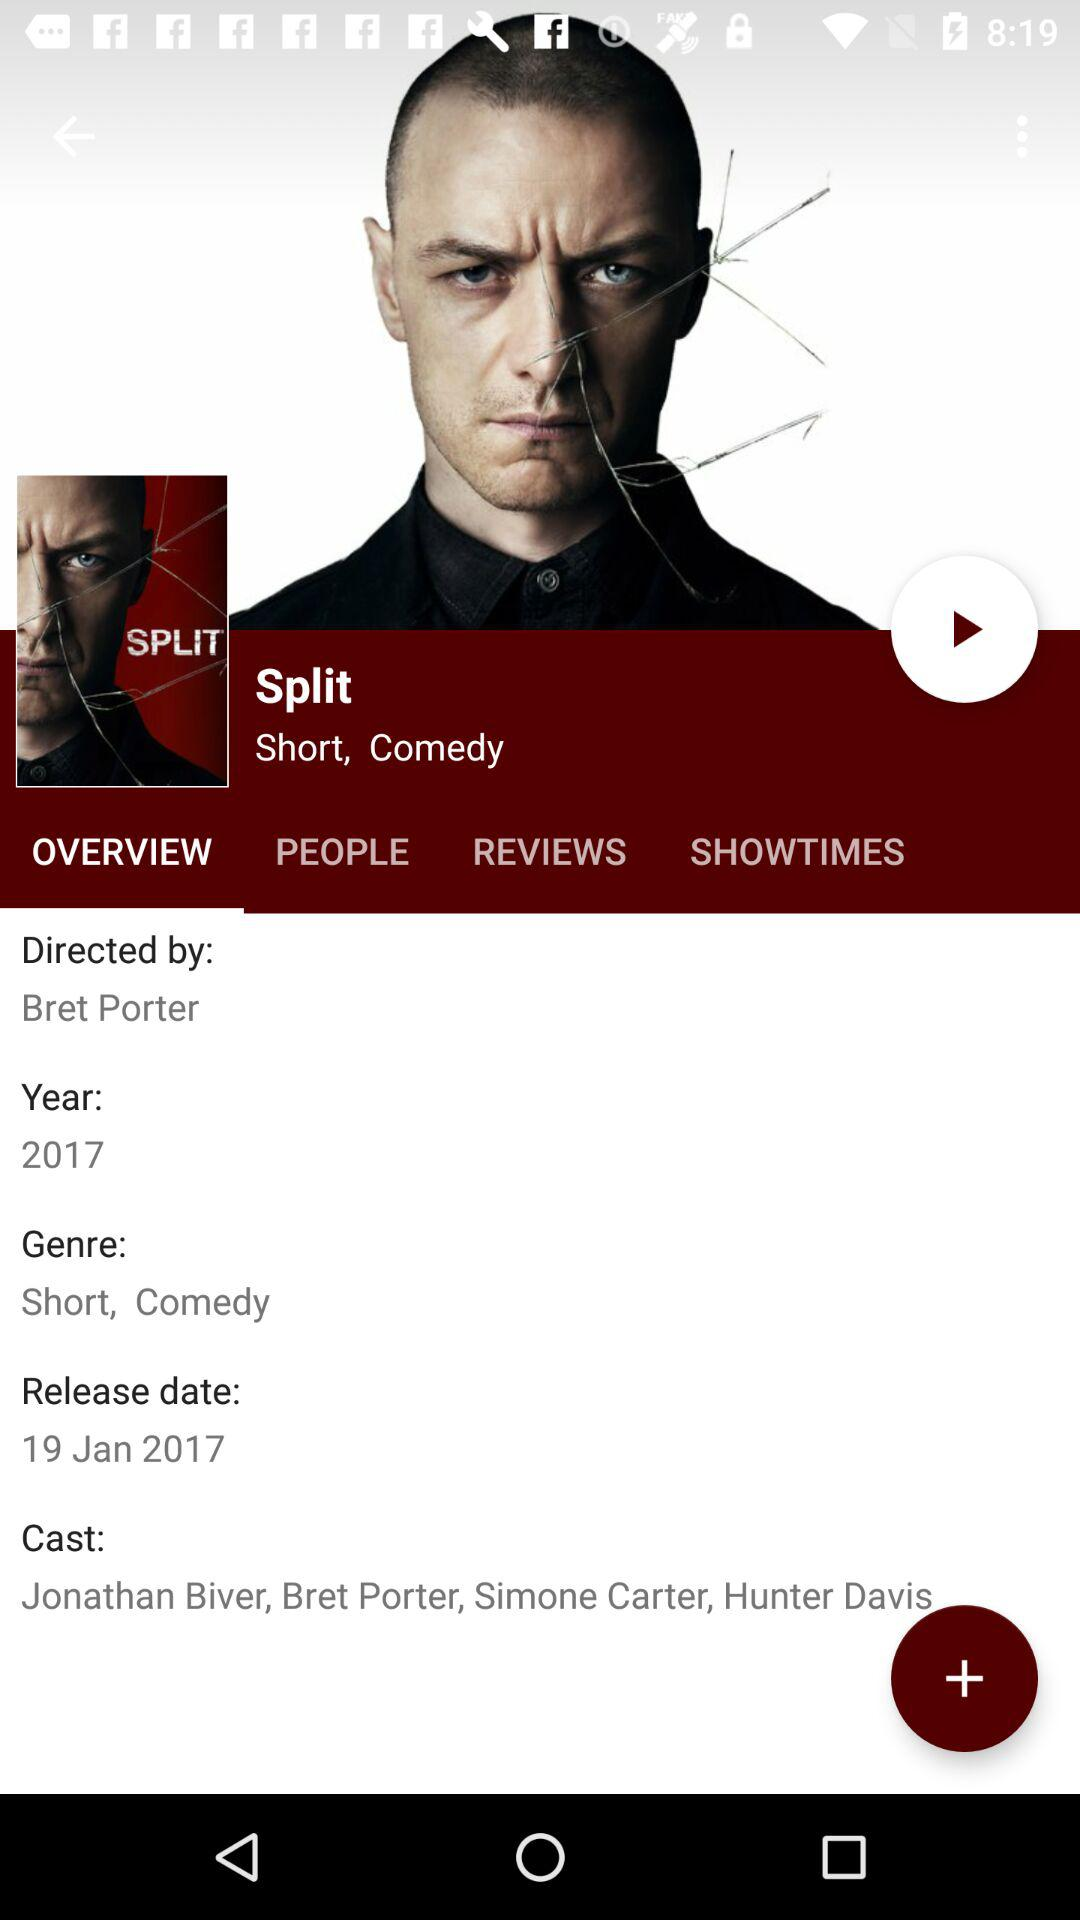What is the release date for the film? The release date is January 19, 2017. 